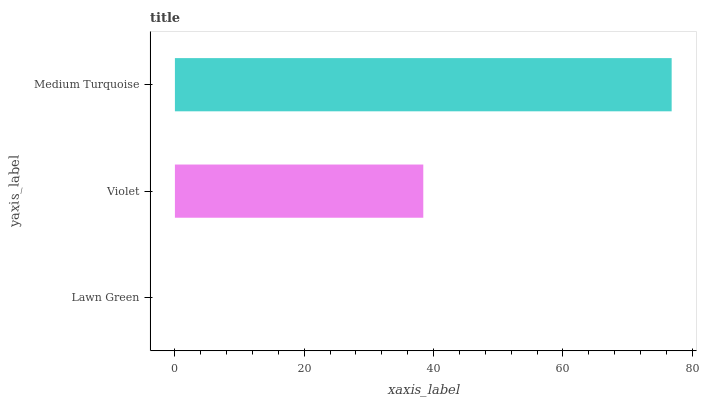Is Lawn Green the minimum?
Answer yes or no. Yes. Is Medium Turquoise the maximum?
Answer yes or no. Yes. Is Violet the minimum?
Answer yes or no. No. Is Violet the maximum?
Answer yes or no. No. Is Violet greater than Lawn Green?
Answer yes or no. Yes. Is Lawn Green less than Violet?
Answer yes or no. Yes. Is Lawn Green greater than Violet?
Answer yes or no. No. Is Violet less than Lawn Green?
Answer yes or no. No. Is Violet the high median?
Answer yes or no. Yes. Is Violet the low median?
Answer yes or no. Yes. Is Lawn Green the high median?
Answer yes or no. No. Is Lawn Green the low median?
Answer yes or no. No. 